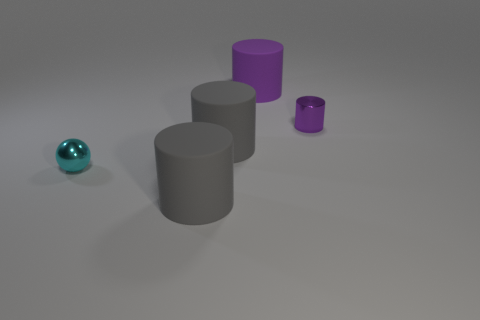How many objects are big brown rubber cubes or big cylinders?
Keep it short and to the point. 3. What size is the other purple thing that is the same shape as the big purple matte thing?
Ensure brevity in your answer.  Small. Are there more balls on the right side of the purple metal object than large red blocks?
Make the answer very short. No. Does the tiny purple cylinder have the same material as the small cyan ball?
Provide a short and direct response. Yes. What number of objects are purple things on the right side of the big purple cylinder or large matte cylinders that are to the left of the big purple matte cylinder?
Offer a very short reply. 3. The small shiny object that is the same shape as the large purple matte thing is what color?
Your response must be concise. Purple. How many metallic objects are the same color as the metal ball?
Give a very brief answer. 0. Does the tiny cylinder have the same color as the metallic sphere?
Keep it short and to the point. No. How many things are either big gray rubber cylinders in front of the small purple thing or big purple rubber cylinders?
Give a very brief answer. 3. There is a metal thing that is to the left of the big purple cylinder that is behind the object that is in front of the tiny shiny ball; what is its color?
Offer a very short reply. Cyan. 